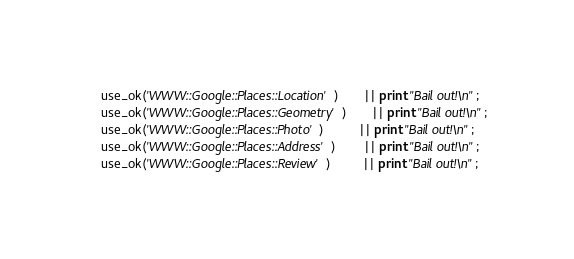Convert code to text. <code><loc_0><loc_0><loc_500><loc_500><_Perl_>    use_ok('WWW::Google::Places::Location')       || print "Bail out!\n";
    use_ok('WWW::Google::Places::Geometry')       || print "Bail out!\n";
    use_ok('WWW::Google::Places::Photo')          || print "Bail out!\n";
    use_ok('WWW::Google::Places::Address')        || print "Bail out!\n";
    use_ok('WWW::Google::Places::Review')         || print "Bail out!\n";</code> 